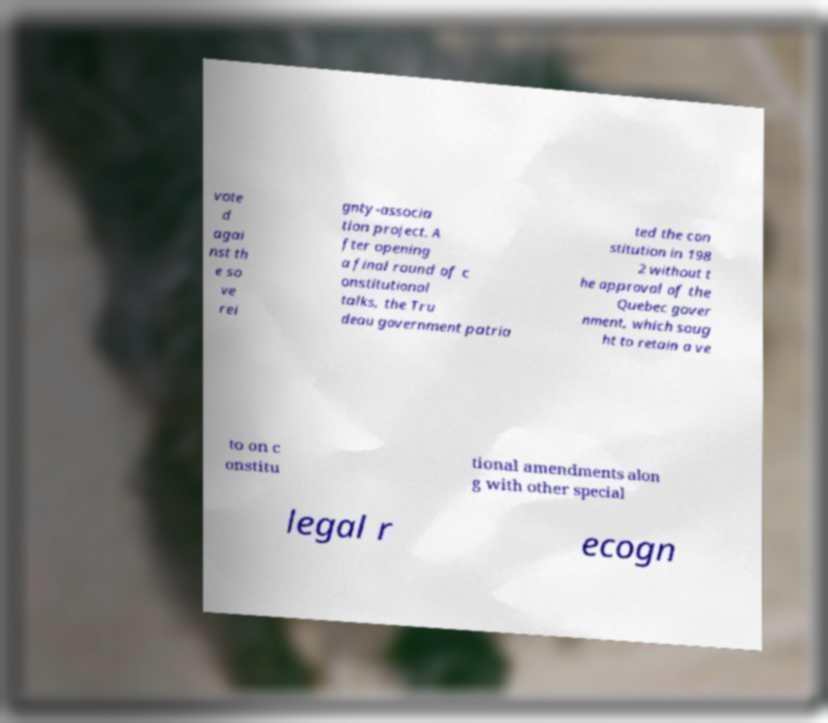For documentation purposes, I need the text within this image transcribed. Could you provide that? vote d agai nst th e so ve rei gnty-associa tion project. A fter opening a final round of c onstitutional talks, the Tru deau government patria ted the con stitution in 198 2 without t he approval of the Quebec gover nment, which soug ht to retain a ve to on c onstitu tional amendments alon g with other special legal r ecogn 